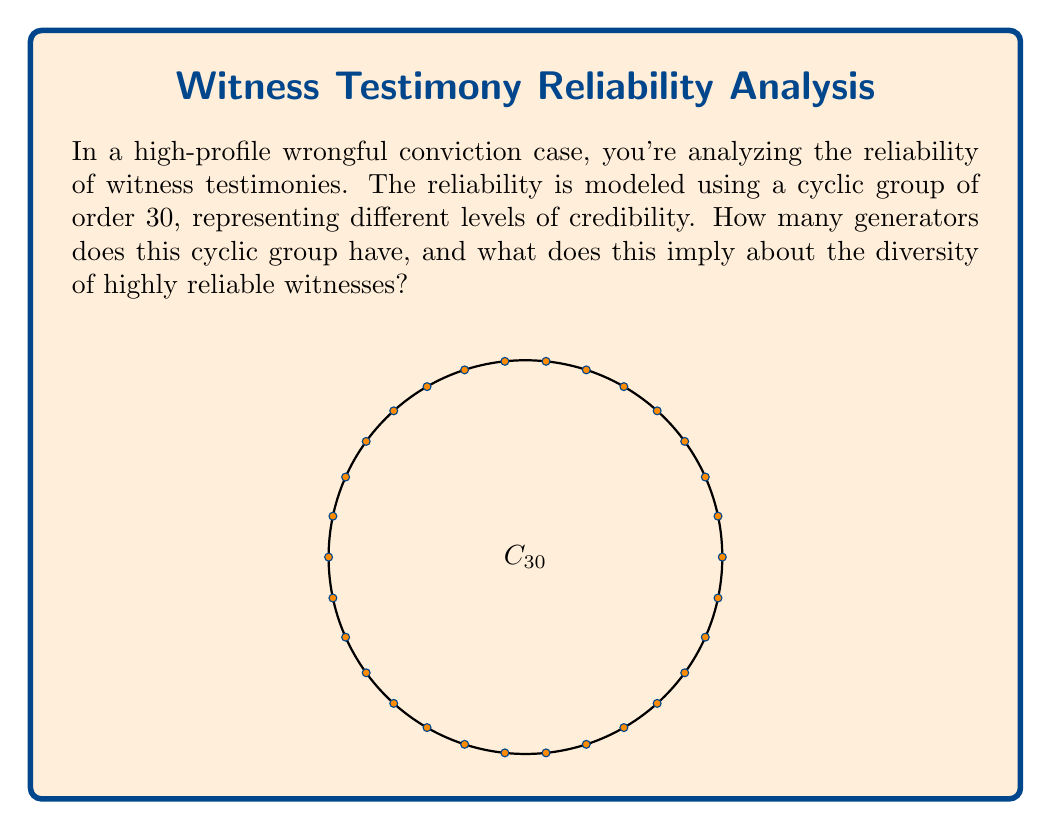Provide a solution to this math problem. To find the number of generators for a cyclic group of order 30, we need to follow these steps:

1) In a cyclic group $C_n$ of order $n$, an element $a$ is a generator if and only if $\gcd(a,n) = 1$.

2) Therefore, we need to count the number of integers $a$ between 1 and 30 (inclusive) that are coprime to 30.

3) To find these numbers, let's first factorize 30:
   $30 = 2 \times 3 \times 5$

4) The numbers coprime to 30 are those that don't share any prime factors with 30. In other words, they are not divisible by 2, 3, or 5.

5) We can use the Euler totient function $\phi(30)$ to count these numbers:

   $\phi(30) = 30 \times (1 - \frac{1}{2}) \times (1 - \frac{1}{3}) \times (1 - \frac{1}{5})$

6) Calculating:
   $\phi(30) = 30 \times \frac{1}{2} \times \frac{2}{3} \times \frac{4}{5} = 8$

7) Therefore, there are 8 generators for this cyclic group.

In the context of witness reliability, this implies that out of 30 possible levels of credibility, there are 8 levels that can generate all other levels through repeated "application" or "combination". These 8 levels represent the most diverse and influential reliability ratings in your witness credibility model.
Answer: 8 generators 